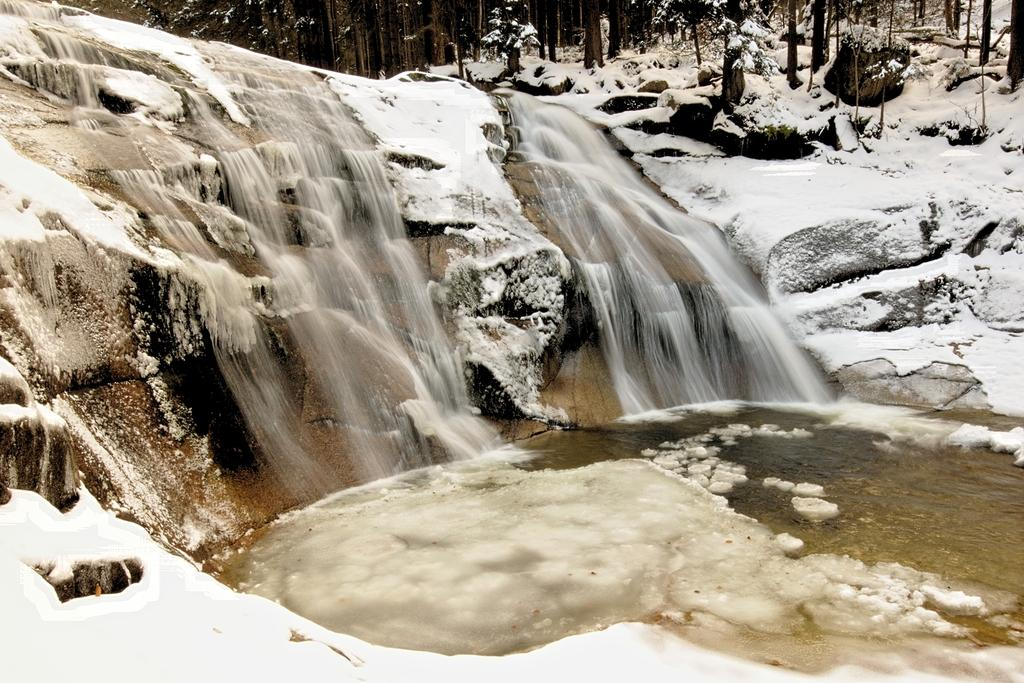What natural feature is the main subject of the image? There is a waterfall in the image. What type of weather condition is depicted in the image? There is snow in the image. What type of vegetation can be seen in the image? There are trees in the image. What type of pipe can be seen in the image? There is no pipe present in the image. What type of pot is used to collect the water from the waterfall in the image? There is no pot present in the image; the waterfall is depicted in its natural state. 